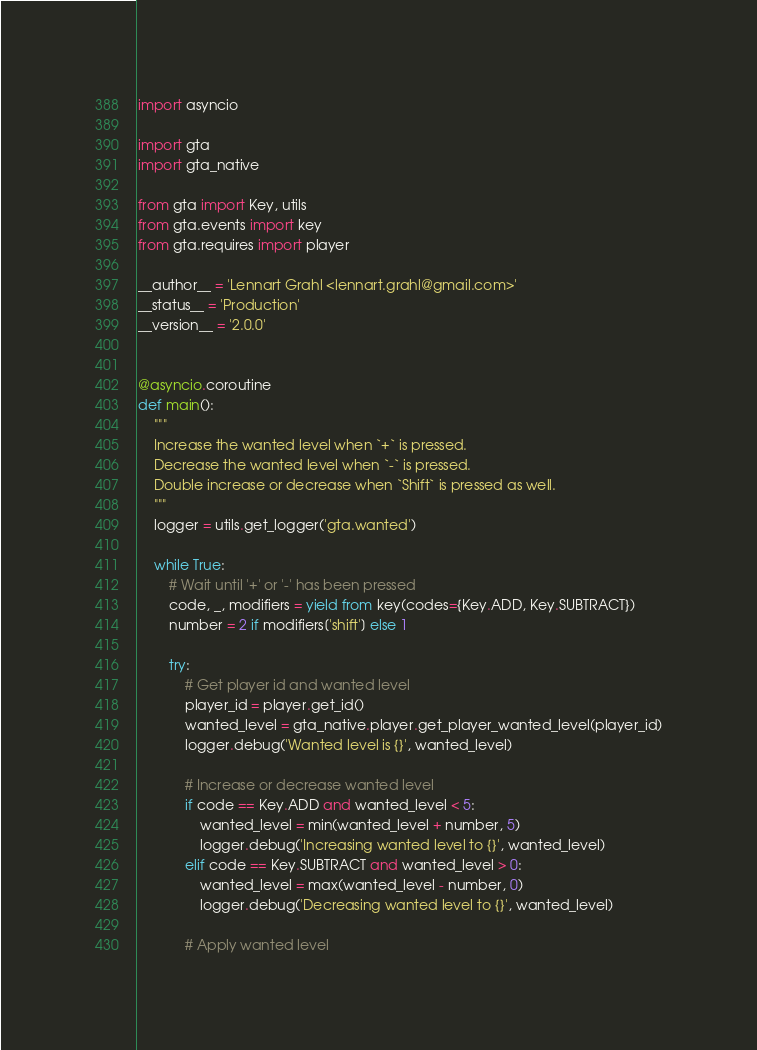<code> <loc_0><loc_0><loc_500><loc_500><_Python_>import asyncio

import gta
import gta_native

from gta import Key, utils
from gta.events import key
from gta.requires import player

__author__ = 'Lennart Grahl <lennart.grahl@gmail.com>'
__status__ = 'Production'
__version__ = '2.0.0'


@asyncio.coroutine
def main():
    """
    Increase the wanted level when `+` is pressed.
    Decrease the wanted level when `-` is pressed.
    Double increase or decrease when `Shift` is pressed as well.
    """
    logger = utils.get_logger('gta.wanted')

    while True:
        # Wait until '+' or '-' has been pressed
        code, _, modifiers = yield from key(codes={Key.ADD, Key.SUBTRACT})
        number = 2 if modifiers['shift'] else 1

        try:
            # Get player id and wanted level
            player_id = player.get_id()
            wanted_level = gta_native.player.get_player_wanted_level(player_id)
            logger.debug('Wanted level is {}', wanted_level)

            # Increase or decrease wanted level
            if code == Key.ADD and wanted_level < 5:
                wanted_level = min(wanted_level + number, 5)
                logger.debug('Increasing wanted level to {}', wanted_level)
            elif code == Key.SUBTRACT and wanted_level > 0:
                wanted_level = max(wanted_level - number, 0)
                logger.debug('Decreasing wanted level to {}', wanted_level)

            # Apply wanted level</code> 